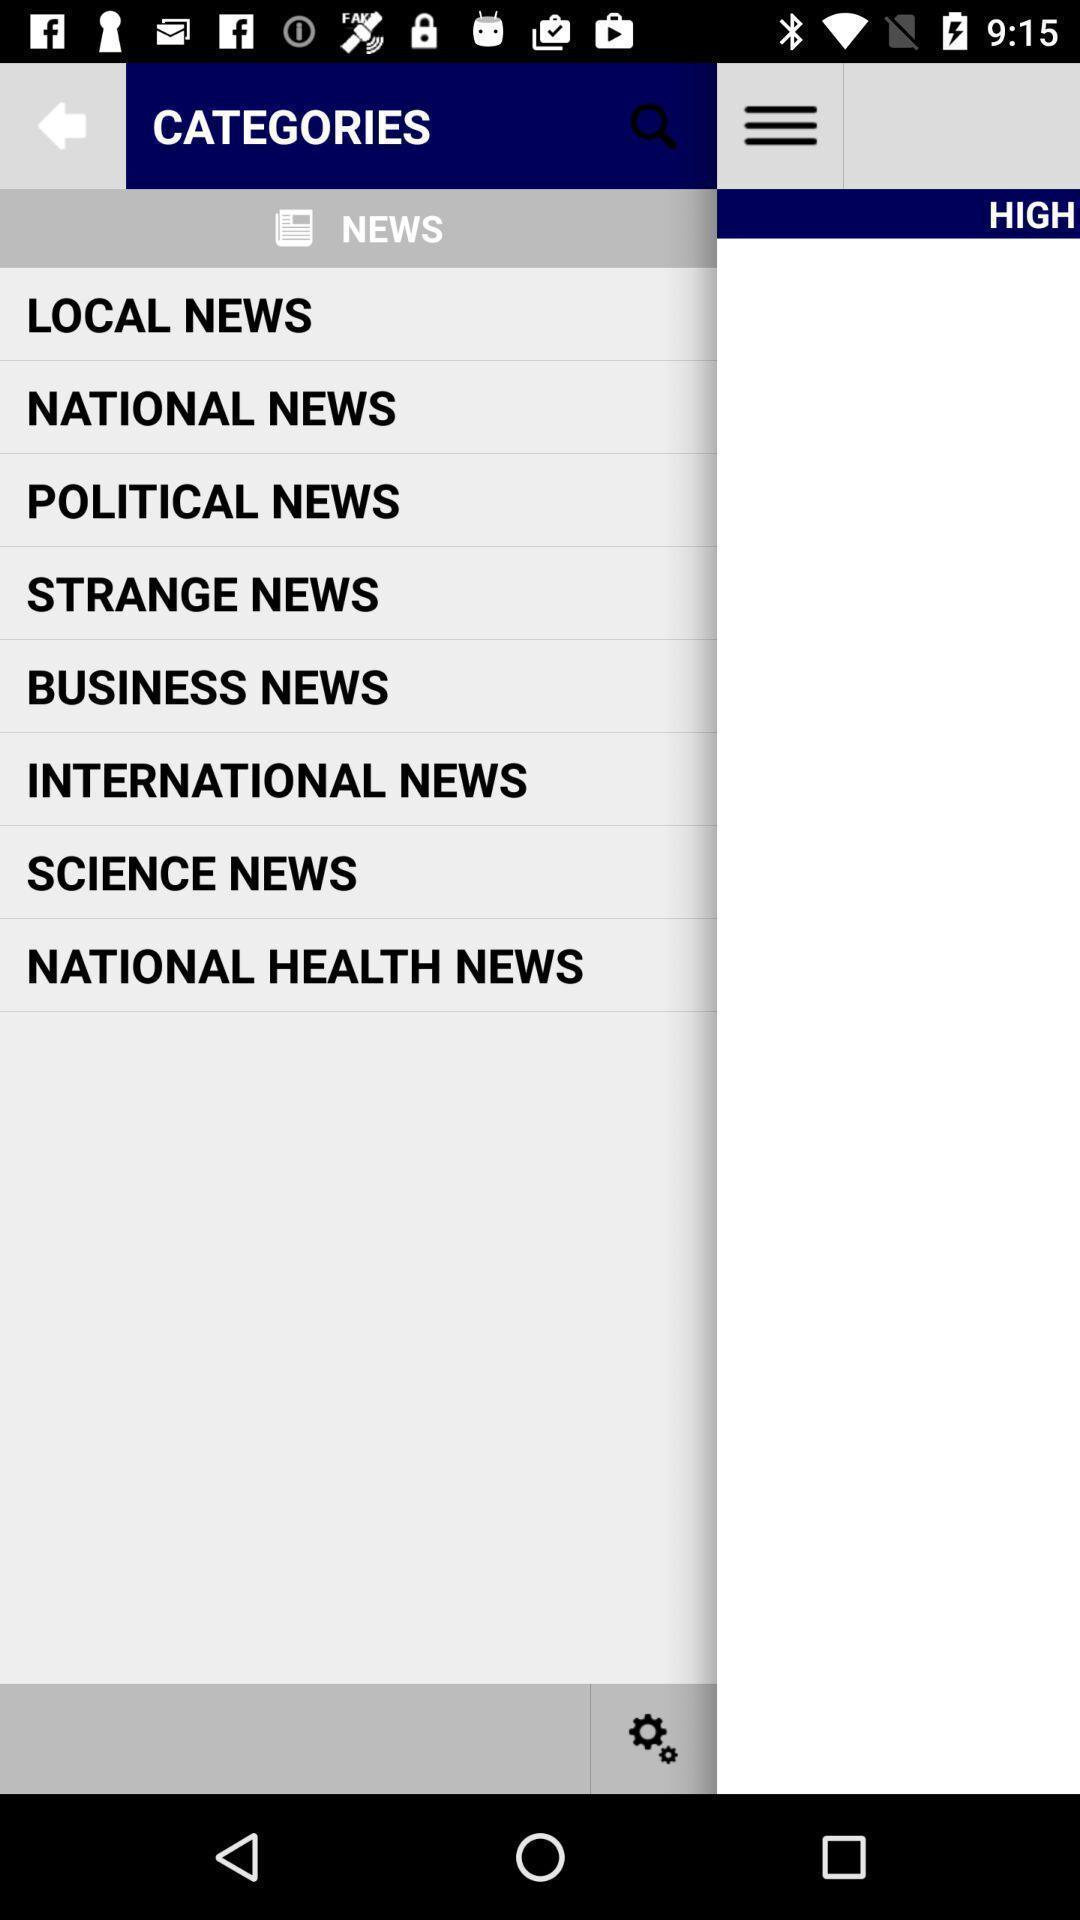Describe this image in words. Screen displaying list of various categories in news app. 